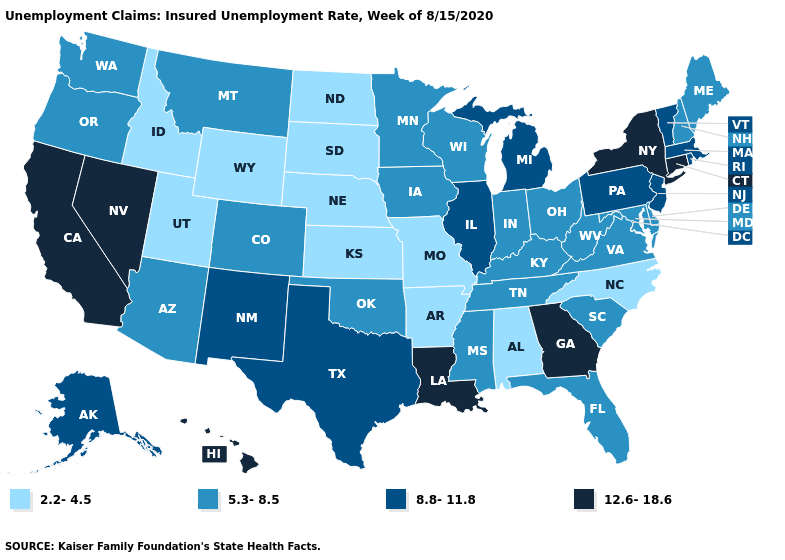What is the value of Iowa?
Answer briefly. 5.3-8.5. Name the states that have a value in the range 8.8-11.8?
Quick response, please. Alaska, Illinois, Massachusetts, Michigan, New Jersey, New Mexico, Pennsylvania, Rhode Island, Texas, Vermont. What is the lowest value in the Northeast?
Answer briefly. 5.3-8.5. What is the highest value in states that border Michigan?
Be succinct. 5.3-8.5. Name the states that have a value in the range 5.3-8.5?
Write a very short answer. Arizona, Colorado, Delaware, Florida, Indiana, Iowa, Kentucky, Maine, Maryland, Minnesota, Mississippi, Montana, New Hampshire, Ohio, Oklahoma, Oregon, South Carolina, Tennessee, Virginia, Washington, West Virginia, Wisconsin. What is the lowest value in states that border Florida?
Answer briefly. 2.2-4.5. Name the states that have a value in the range 5.3-8.5?
Be succinct. Arizona, Colorado, Delaware, Florida, Indiana, Iowa, Kentucky, Maine, Maryland, Minnesota, Mississippi, Montana, New Hampshire, Ohio, Oklahoma, Oregon, South Carolina, Tennessee, Virginia, Washington, West Virginia, Wisconsin. Name the states that have a value in the range 12.6-18.6?
Short answer required. California, Connecticut, Georgia, Hawaii, Louisiana, Nevada, New York. Does Illinois have a lower value than California?
Keep it brief. Yes. Does New York have the highest value in the Northeast?
Write a very short answer. Yes. Name the states that have a value in the range 8.8-11.8?
Short answer required. Alaska, Illinois, Massachusetts, Michigan, New Jersey, New Mexico, Pennsylvania, Rhode Island, Texas, Vermont. Does Louisiana have the highest value in the South?
Keep it brief. Yes. Name the states that have a value in the range 2.2-4.5?
Concise answer only. Alabama, Arkansas, Idaho, Kansas, Missouri, Nebraska, North Carolina, North Dakota, South Dakota, Utah, Wyoming. What is the value of Illinois?
Concise answer only. 8.8-11.8. Does the first symbol in the legend represent the smallest category?
Answer briefly. Yes. 